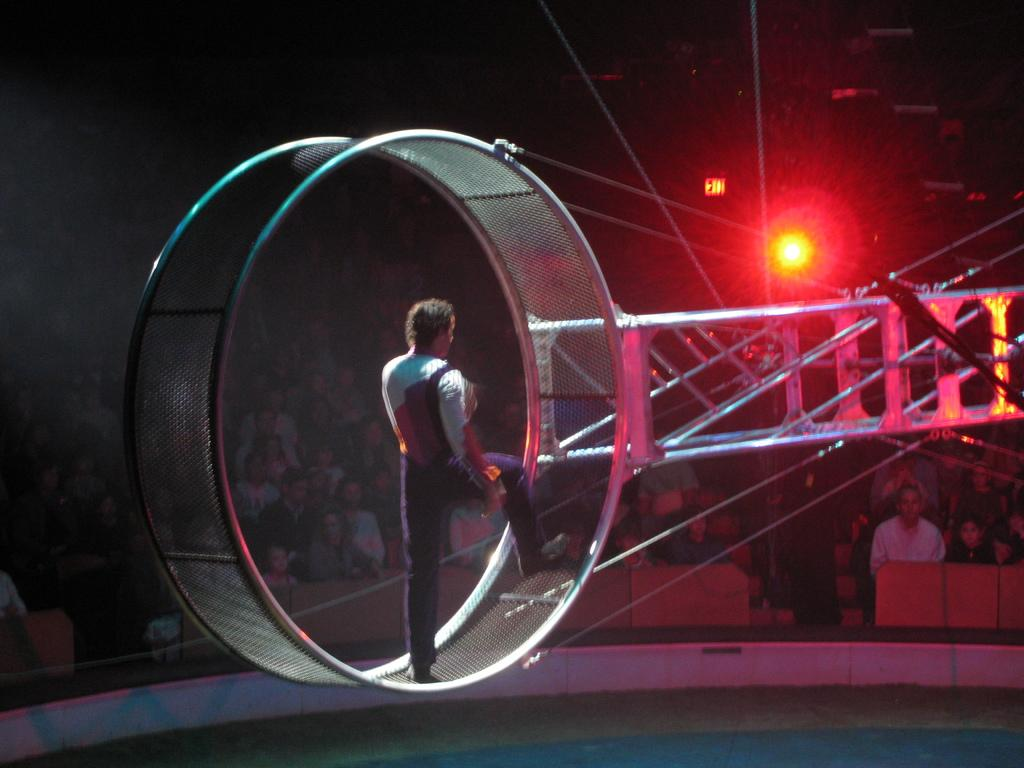What is the man in the image standing on? The man is standing on a circular mesh. What other objects can be seen in the image besides the man? There are rods visible in the image. Can you describe the background of the image? The background of the image is dark, and there are people, a board, and a focusing light present. What type of crayon is being used by the man in the image? There is no crayon present in the image, and the man is not using any crayons. Can you hear the people in the background of the image? The image is a visual representation, and there is no sound or audio associated with it, so it is not possible to hear the people in the background. 